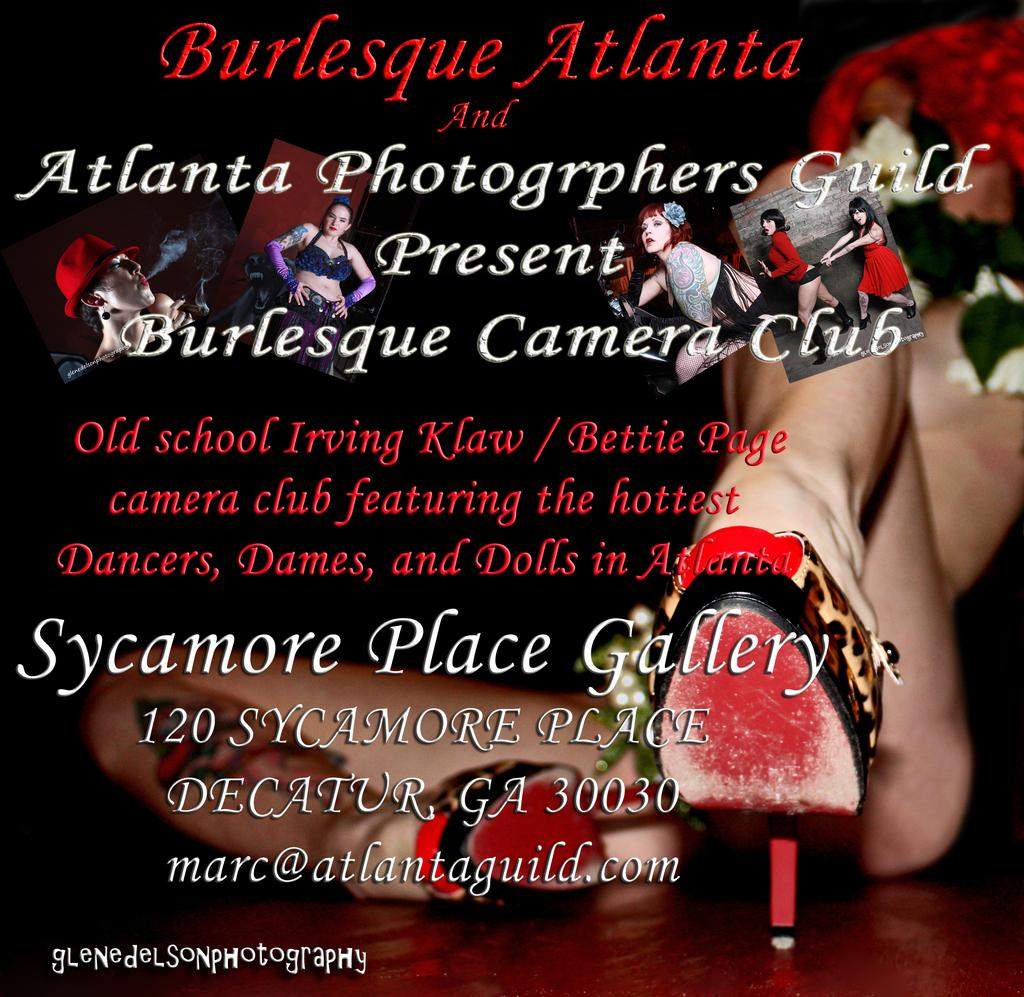What is featured on the poster in the image? The poster contains text and pictures. Can you describe the content of the poster? Unfortunately, the specific content of the poster cannot be determined from the provided facts. What part of a person can be seen in the image? Human legs are visible in the image. What type of footwear is present in the image? Sandals are present in the image. How does the crowd react to the stitch in the image? There is no crowd present in the image, and therefore no reaction to a stitch can be observed. 